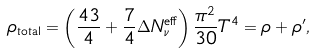<formula> <loc_0><loc_0><loc_500><loc_500>\rho _ { \text {total} } = \left ( \frac { 4 3 } { 4 } + \frac { 7 } { 4 } \Delta N _ { \nu } ^ { \text {eff} } \right ) \frac { \pi ^ { 2 } } { 3 0 } T ^ { 4 } = \rho + \rho ^ { \prime } ,</formula> 